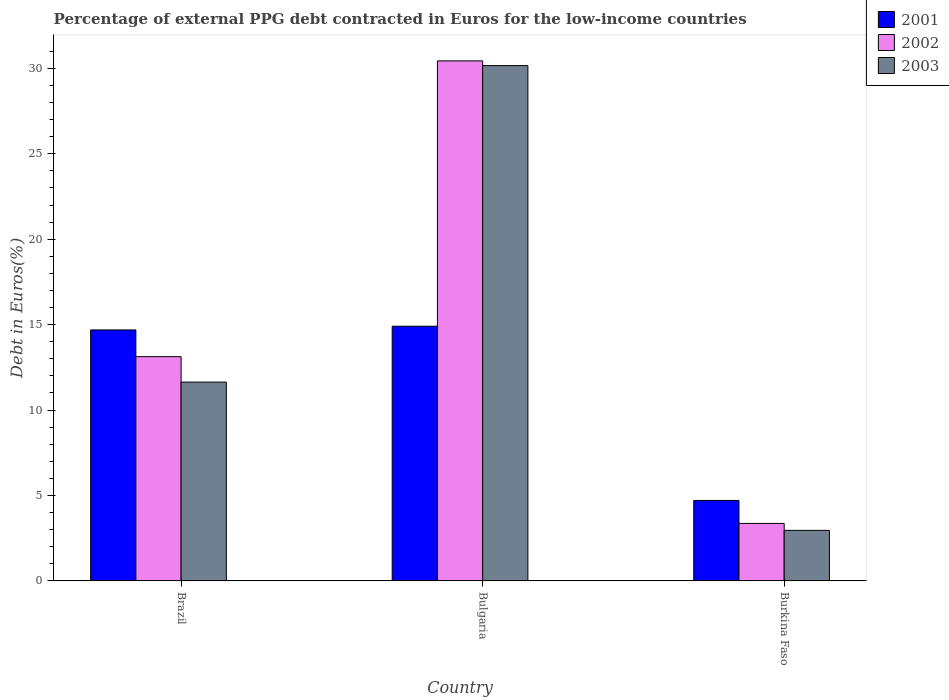How many different coloured bars are there?
Offer a terse response. 3. Are the number of bars per tick equal to the number of legend labels?
Your answer should be very brief. Yes. How many bars are there on the 3rd tick from the left?
Make the answer very short. 3. What is the label of the 1st group of bars from the left?
Your answer should be compact. Brazil. What is the percentage of external PPG debt contracted in Euros in 2001 in Brazil?
Offer a very short reply. 14.69. Across all countries, what is the maximum percentage of external PPG debt contracted in Euros in 2003?
Provide a short and direct response. 30.16. Across all countries, what is the minimum percentage of external PPG debt contracted in Euros in 2001?
Ensure brevity in your answer.  4.71. In which country was the percentage of external PPG debt contracted in Euros in 2001 minimum?
Ensure brevity in your answer.  Burkina Faso. What is the total percentage of external PPG debt contracted in Euros in 2003 in the graph?
Keep it short and to the point. 44.76. What is the difference between the percentage of external PPG debt contracted in Euros in 2001 in Bulgaria and that in Burkina Faso?
Your response must be concise. 10.2. What is the difference between the percentage of external PPG debt contracted in Euros in 2003 in Brazil and the percentage of external PPG debt contracted in Euros in 2002 in Burkina Faso?
Provide a short and direct response. 8.27. What is the average percentage of external PPG debt contracted in Euros in 2001 per country?
Offer a terse response. 11.44. What is the difference between the percentage of external PPG debt contracted in Euros of/in 2003 and percentage of external PPG debt contracted in Euros of/in 2002 in Brazil?
Give a very brief answer. -1.49. In how many countries, is the percentage of external PPG debt contracted in Euros in 2003 greater than 5 %?
Give a very brief answer. 2. What is the ratio of the percentage of external PPG debt contracted in Euros in 2003 in Brazil to that in Bulgaria?
Your answer should be compact. 0.39. Is the difference between the percentage of external PPG debt contracted in Euros in 2003 in Brazil and Bulgaria greater than the difference between the percentage of external PPG debt contracted in Euros in 2002 in Brazil and Bulgaria?
Keep it short and to the point. No. What is the difference between the highest and the second highest percentage of external PPG debt contracted in Euros in 2001?
Ensure brevity in your answer.  -10.2. What is the difference between the highest and the lowest percentage of external PPG debt contracted in Euros in 2001?
Provide a short and direct response. 10.2. What does the 1st bar from the right in Bulgaria represents?
Ensure brevity in your answer.  2003. Is it the case that in every country, the sum of the percentage of external PPG debt contracted in Euros in 2002 and percentage of external PPG debt contracted in Euros in 2001 is greater than the percentage of external PPG debt contracted in Euros in 2003?
Offer a terse response. Yes. How many bars are there?
Offer a terse response. 9. Are the values on the major ticks of Y-axis written in scientific E-notation?
Offer a terse response. No. How many legend labels are there?
Your answer should be very brief. 3. What is the title of the graph?
Your response must be concise. Percentage of external PPG debt contracted in Euros for the low-income countries. Does "1975" appear as one of the legend labels in the graph?
Your response must be concise. No. What is the label or title of the X-axis?
Provide a short and direct response. Country. What is the label or title of the Y-axis?
Offer a terse response. Debt in Euros(%). What is the Debt in Euros(%) in 2001 in Brazil?
Your answer should be compact. 14.69. What is the Debt in Euros(%) in 2002 in Brazil?
Provide a succinct answer. 13.13. What is the Debt in Euros(%) in 2003 in Brazil?
Keep it short and to the point. 11.64. What is the Debt in Euros(%) of 2001 in Bulgaria?
Your answer should be compact. 14.91. What is the Debt in Euros(%) in 2002 in Bulgaria?
Keep it short and to the point. 30.44. What is the Debt in Euros(%) in 2003 in Bulgaria?
Offer a terse response. 30.16. What is the Debt in Euros(%) of 2001 in Burkina Faso?
Your response must be concise. 4.71. What is the Debt in Euros(%) of 2002 in Burkina Faso?
Make the answer very short. 3.37. What is the Debt in Euros(%) of 2003 in Burkina Faso?
Your answer should be compact. 2.96. Across all countries, what is the maximum Debt in Euros(%) in 2001?
Offer a terse response. 14.91. Across all countries, what is the maximum Debt in Euros(%) of 2002?
Offer a terse response. 30.44. Across all countries, what is the maximum Debt in Euros(%) in 2003?
Offer a terse response. 30.16. Across all countries, what is the minimum Debt in Euros(%) in 2001?
Your answer should be compact. 4.71. Across all countries, what is the minimum Debt in Euros(%) in 2002?
Your answer should be compact. 3.37. Across all countries, what is the minimum Debt in Euros(%) in 2003?
Your answer should be compact. 2.96. What is the total Debt in Euros(%) in 2001 in the graph?
Offer a terse response. 34.31. What is the total Debt in Euros(%) of 2002 in the graph?
Offer a very short reply. 46.93. What is the total Debt in Euros(%) in 2003 in the graph?
Keep it short and to the point. 44.76. What is the difference between the Debt in Euros(%) in 2001 in Brazil and that in Bulgaria?
Ensure brevity in your answer.  -0.22. What is the difference between the Debt in Euros(%) of 2002 in Brazil and that in Bulgaria?
Ensure brevity in your answer.  -17.31. What is the difference between the Debt in Euros(%) in 2003 in Brazil and that in Bulgaria?
Offer a very short reply. -18.52. What is the difference between the Debt in Euros(%) in 2001 in Brazil and that in Burkina Faso?
Offer a very short reply. 9.98. What is the difference between the Debt in Euros(%) in 2002 in Brazil and that in Burkina Faso?
Provide a succinct answer. 9.76. What is the difference between the Debt in Euros(%) of 2003 in Brazil and that in Burkina Faso?
Keep it short and to the point. 8.68. What is the difference between the Debt in Euros(%) in 2001 in Bulgaria and that in Burkina Faso?
Offer a terse response. 10.2. What is the difference between the Debt in Euros(%) of 2002 in Bulgaria and that in Burkina Faso?
Provide a succinct answer. 27.07. What is the difference between the Debt in Euros(%) of 2003 in Bulgaria and that in Burkina Faso?
Offer a terse response. 27.2. What is the difference between the Debt in Euros(%) of 2001 in Brazil and the Debt in Euros(%) of 2002 in Bulgaria?
Your answer should be compact. -15.75. What is the difference between the Debt in Euros(%) of 2001 in Brazil and the Debt in Euros(%) of 2003 in Bulgaria?
Make the answer very short. -15.47. What is the difference between the Debt in Euros(%) in 2002 in Brazil and the Debt in Euros(%) in 2003 in Bulgaria?
Provide a succinct answer. -17.03. What is the difference between the Debt in Euros(%) of 2001 in Brazil and the Debt in Euros(%) of 2002 in Burkina Faso?
Offer a terse response. 11.32. What is the difference between the Debt in Euros(%) of 2001 in Brazil and the Debt in Euros(%) of 2003 in Burkina Faso?
Offer a very short reply. 11.73. What is the difference between the Debt in Euros(%) of 2002 in Brazil and the Debt in Euros(%) of 2003 in Burkina Faso?
Offer a terse response. 10.17. What is the difference between the Debt in Euros(%) in 2001 in Bulgaria and the Debt in Euros(%) in 2002 in Burkina Faso?
Ensure brevity in your answer.  11.54. What is the difference between the Debt in Euros(%) of 2001 in Bulgaria and the Debt in Euros(%) of 2003 in Burkina Faso?
Provide a short and direct response. 11.95. What is the difference between the Debt in Euros(%) of 2002 in Bulgaria and the Debt in Euros(%) of 2003 in Burkina Faso?
Your response must be concise. 27.48. What is the average Debt in Euros(%) in 2001 per country?
Offer a very short reply. 11.44. What is the average Debt in Euros(%) of 2002 per country?
Make the answer very short. 15.64. What is the average Debt in Euros(%) in 2003 per country?
Make the answer very short. 14.92. What is the difference between the Debt in Euros(%) of 2001 and Debt in Euros(%) of 2002 in Brazil?
Your answer should be very brief. 1.56. What is the difference between the Debt in Euros(%) of 2001 and Debt in Euros(%) of 2003 in Brazil?
Provide a short and direct response. 3.05. What is the difference between the Debt in Euros(%) in 2002 and Debt in Euros(%) in 2003 in Brazil?
Give a very brief answer. 1.49. What is the difference between the Debt in Euros(%) in 2001 and Debt in Euros(%) in 2002 in Bulgaria?
Make the answer very short. -15.53. What is the difference between the Debt in Euros(%) of 2001 and Debt in Euros(%) of 2003 in Bulgaria?
Make the answer very short. -15.25. What is the difference between the Debt in Euros(%) in 2002 and Debt in Euros(%) in 2003 in Bulgaria?
Offer a terse response. 0.28. What is the difference between the Debt in Euros(%) of 2001 and Debt in Euros(%) of 2002 in Burkina Faso?
Give a very brief answer. 1.35. What is the difference between the Debt in Euros(%) in 2001 and Debt in Euros(%) in 2003 in Burkina Faso?
Offer a terse response. 1.75. What is the difference between the Debt in Euros(%) of 2002 and Debt in Euros(%) of 2003 in Burkina Faso?
Your answer should be very brief. 0.41. What is the ratio of the Debt in Euros(%) in 2001 in Brazil to that in Bulgaria?
Provide a short and direct response. 0.99. What is the ratio of the Debt in Euros(%) in 2002 in Brazil to that in Bulgaria?
Ensure brevity in your answer.  0.43. What is the ratio of the Debt in Euros(%) in 2003 in Brazil to that in Bulgaria?
Make the answer very short. 0.39. What is the ratio of the Debt in Euros(%) of 2001 in Brazil to that in Burkina Faso?
Make the answer very short. 3.12. What is the ratio of the Debt in Euros(%) in 2002 in Brazil to that in Burkina Faso?
Your answer should be very brief. 3.9. What is the ratio of the Debt in Euros(%) of 2003 in Brazil to that in Burkina Faso?
Offer a terse response. 3.93. What is the ratio of the Debt in Euros(%) in 2001 in Bulgaria to that in Burkina Faso?
Provide a short and direct response. 3.16. What is the ratio of the Debt in Euros(%) in 2002 in Bulgaria to that in Burkina Faso?
Make the answer very short. 9.04. What is the ratio of the Debt in Euros(%) of 2003 in Bulgaria to that in Burkina Faso?
Keep it short and to the point. 10.19. What is the difference between the highest and the second highest Debt in Euros(%) of 2001?
Ensure brevity in your answer.  0.22. What is the difference between the highest and the second highest Debt in Euros(%) of 2002?
Provide a succinct answer. 17.31. What is the difference between the highest and the second highest Debt in Euros(%) in 2003?
Your response must be concise. 18.52. What is the difference between the highest and the lowest Debt in Euros(%) in 2001?
Keep it short and to the point. 10.2. What is the difference between the highest and the lowest Debt in Euros(%) in 2002?
Give a very brief answer. 27.07. What is the difference between the highest and the lowest Debt in Euros(%) in 2003?
Offer a very short reply. 27.2. 